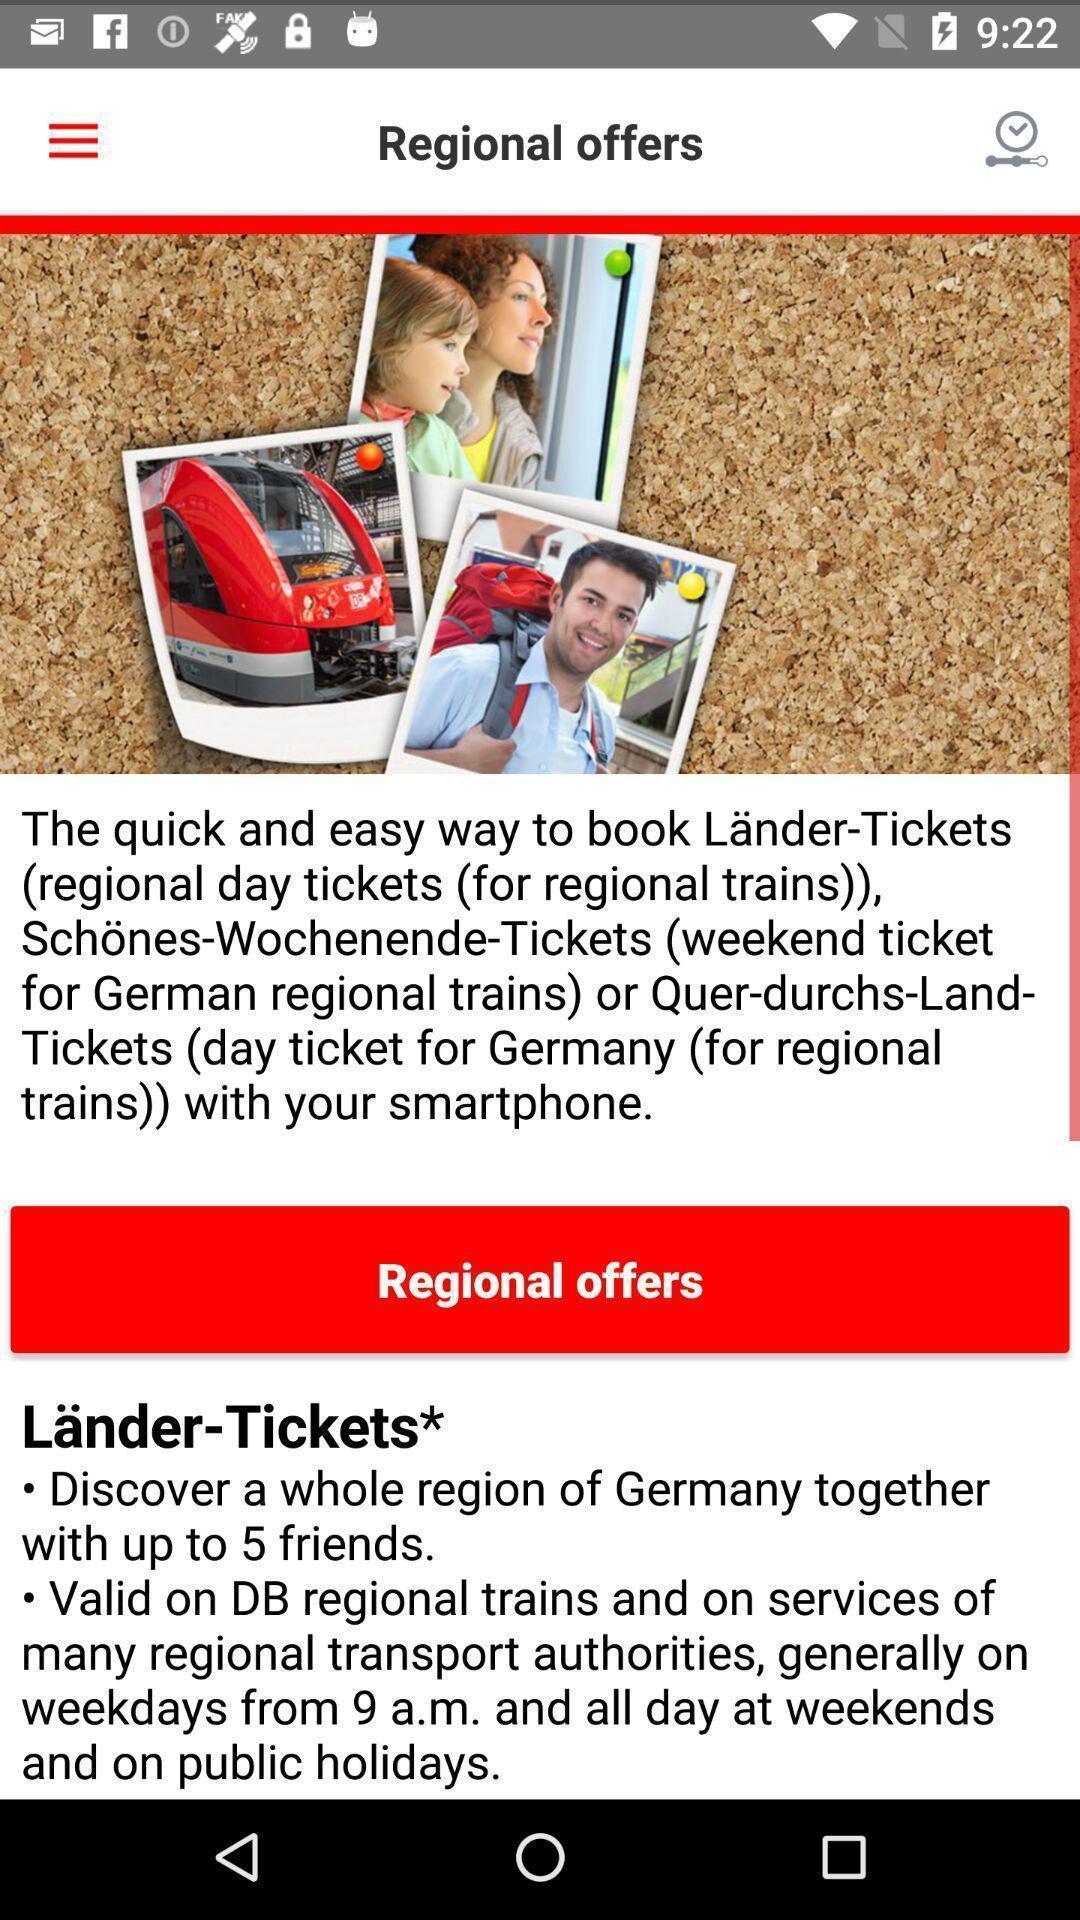Provide a detailed account of this screenshot. Various info displayed of a bookings app. 